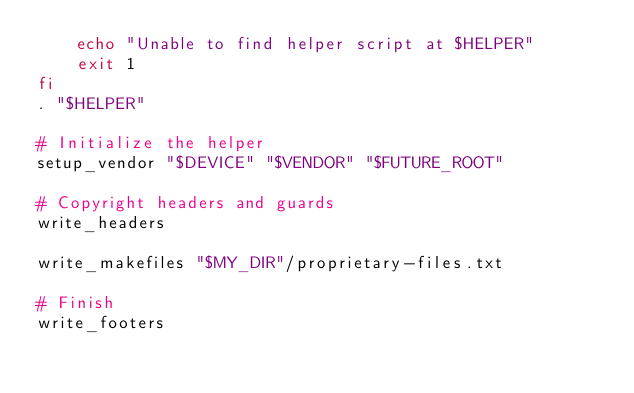<code> <loc_0><loc_0><loc_500><loc_500><_Bash_>    echo "Unable to find helper script at $HELPER"
    exit 1
fi
. "$HELPER"

# Initialize the helper
setup_vendor "$DEVICE" "$VENDOR" "$FUTURE_ROOT"

# Copyright headers and guards
write_headers

write_makefiles "$MY_DIR"/proprietary-files.txt

# Finish
write_footers
</code> 